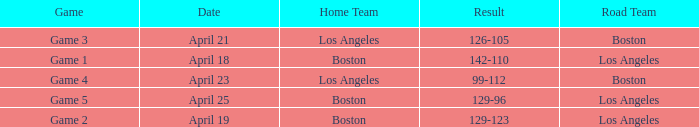WHAT IS THE DATE WITH BOSTON ROAD TEAM AND 126-105 RESULT? April 21. 